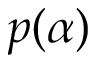Convert formula to latex. <formula><loc_0><loc_0><loc_500><loc_500>p ( \alpha )</formula> 